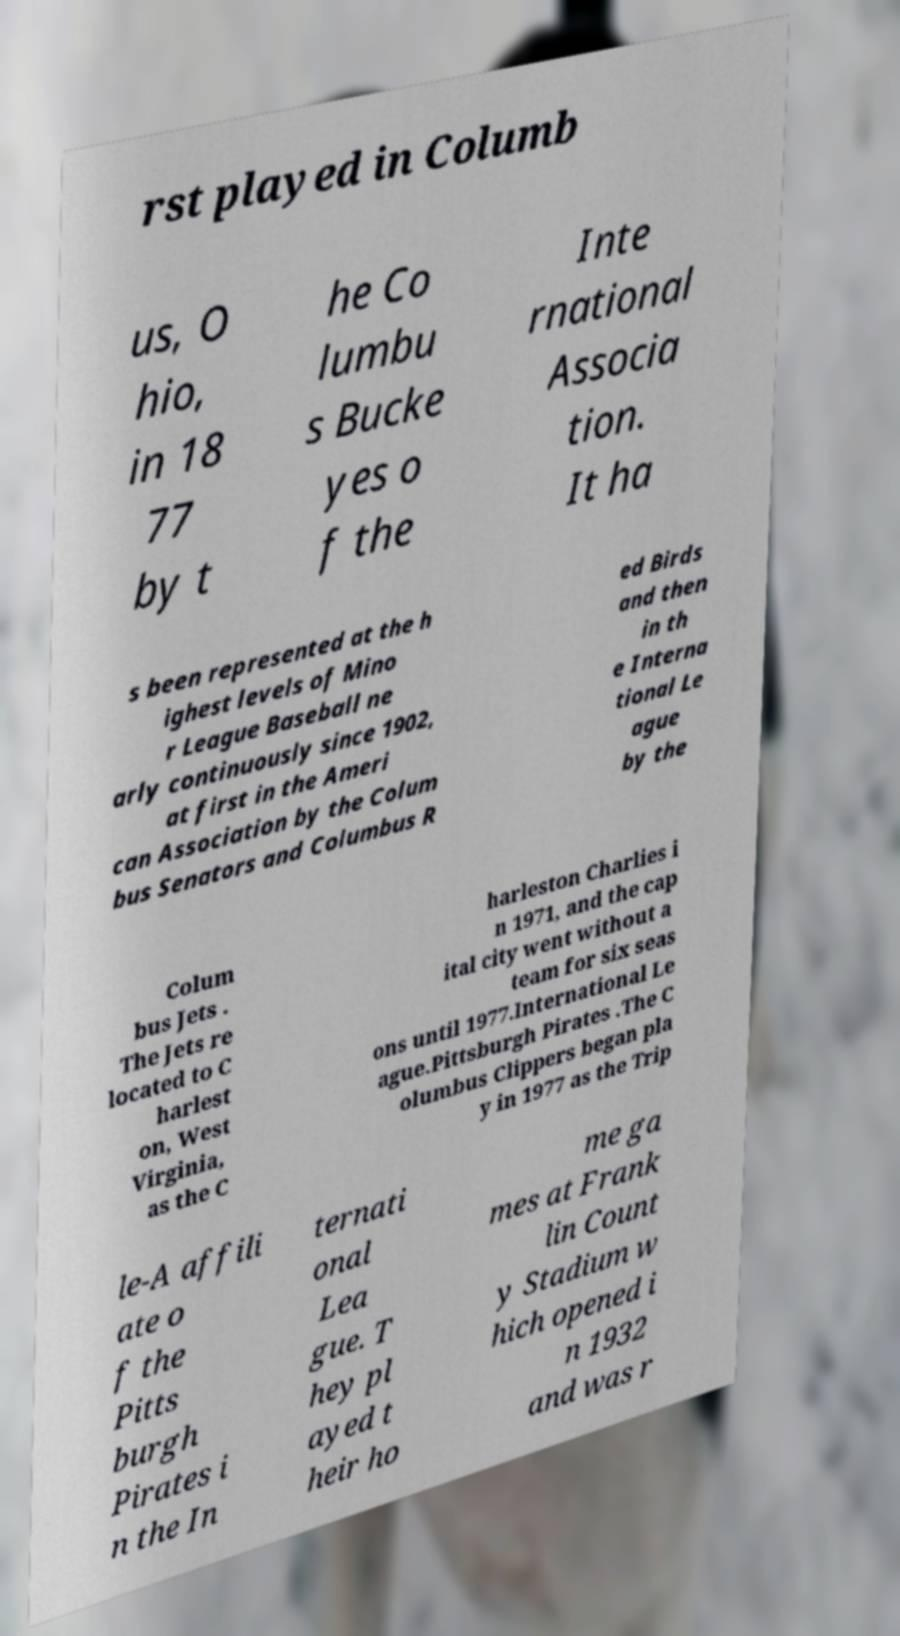Please read and relay the text visible in this image. What does it say? rst played in Columb us, O hio, in 18 77 by t he Co lumbu s Bucke yes o f the Inte rnational Associa tion. It ha s been represented at the h ighest levels of Mino r League Baseball ne arly continuously since 1902, at first in the Ameri can Association by the Colum bus Senators and Columbus R ed Birds and then in th e Interna tional Le ague by the Colum bus Jets . The Jets re located to C harlest on, West Virginia, as the C harleston Charlies i n 1971, and the cap ital city went without a team for six seas ons until 1977.International Le ague.Pittsburgh Pirates .The C olumbus Clippers began pla y in 1977 as the Trip le-A affili ate o f the Pitts burgh Pirates i n the In ternati onal Lea gue. T hey pl ayed t heir ho me ga mes at Frank lin Count y Stadium w hich opened i n 1932 and was r 